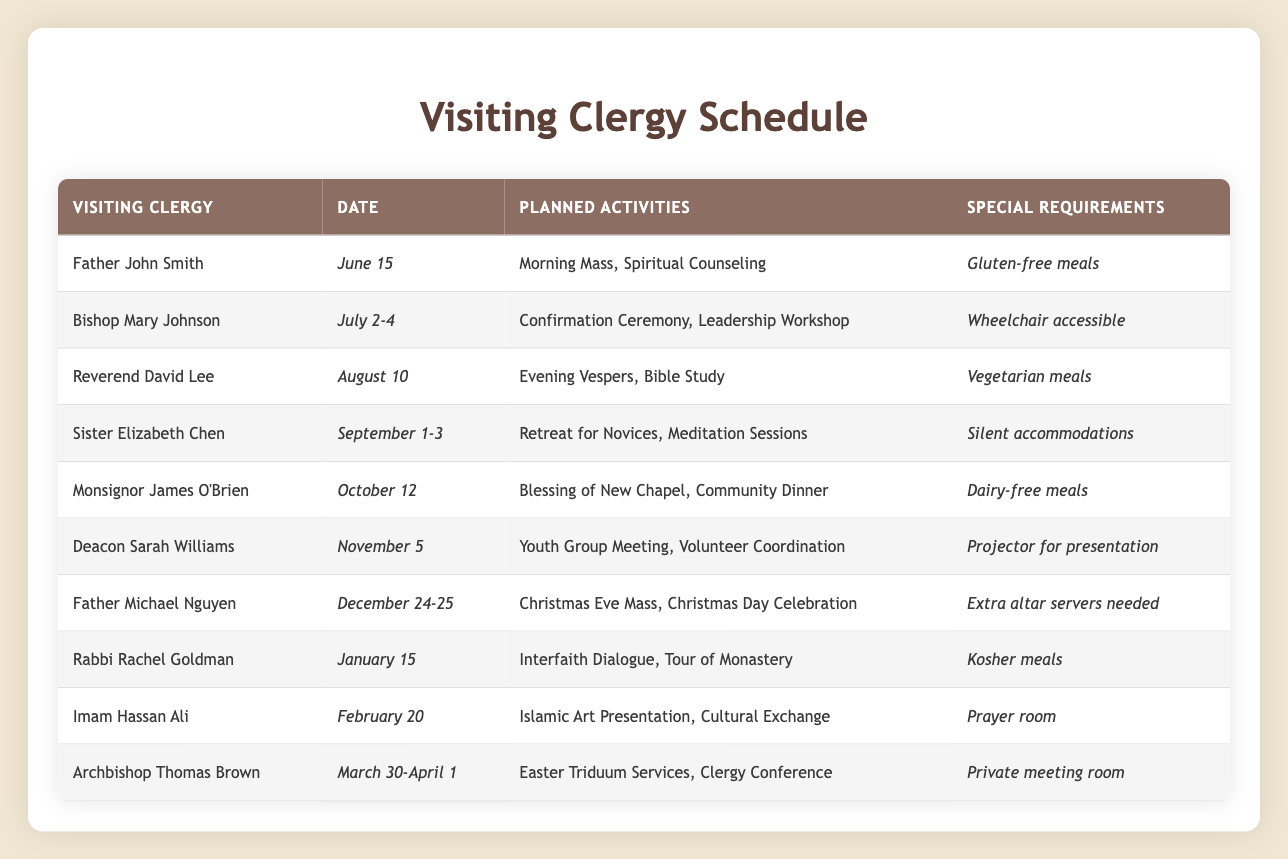What activities is Father John Smith planning on June 15? According to the table, Father John Smith is scheduled for "Morning Mass" and "Spiritual Counseling" on June 15.
Answer: Morning Mass, Spiritual Counseling How many days will Bishop Mary Johnson be visiting? The date for Bishop Mary Johnson is listed as July 2-4, which indicates a duration of 3 days (July 2, July 3, and July 4).
Answer: 3 days Is there a vegetarian meal requirement for any visiting clergy? Yes, Reverend David Lee has specified "Vegetarian meals" as a special requirement for his visit on August 10.
Answer: Yes What is the main activity planned for Sister Elizabeth Chen's visit? Sister Elizabeth Chen is planning a "Retreat for Novices" along with "Meditation Sessions" during her visit from September 1-3.
Answer: Retreat for Novices, Meditation Sessions How many clergy are scheduled to visit in the month of December? From the table, Father Michael Nguyen is the only clergy visiting in December, specifically on December 24-25. Thus, there is 1 clergy scheduled for that month.
Answer: 1 